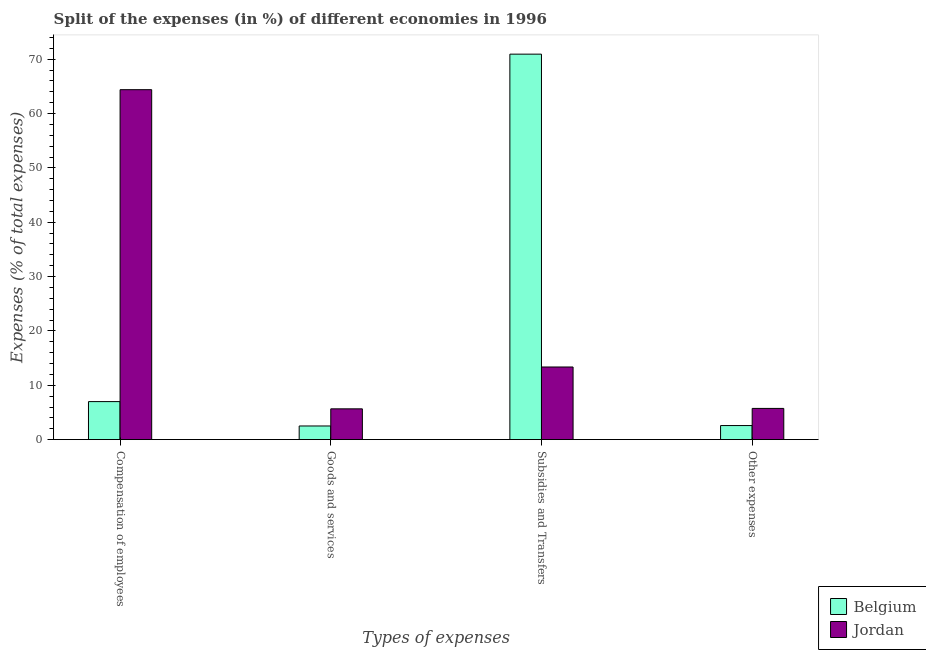How many groups of bars are there?
Keep it short and to the point. 4. Are the number of bars per tick equal to the number of legend labels?
Your answer should be very brief. Yes. Are the number of bars on each tick of the X-axis equal?
Ensure brevity in your answer.  Yes. What is the label of the 4th group of bars from the left?
Provide a succinct answer. Other expenses. What is the percentage of amount spent on goods and services in Belgium?
Ensure brevity in your answer.  2.51. Across all countries, what is the maximum percentage of amount spent on goods and services?
Give a very brief answer. 5.66. Across all countries, what is the minimum percentage of amount spent on subsidies?
Your response must be concise. 13.36. What is the total percentage of amount spent on compensation of employees in the graph?
Your answer should be very brief. 71.39. What is the difference between the percentage of amount spent on other expenses in Jordan and that in Belgium?
Your answer should be very brief. 3.15. What is the difference between the percentage of amount spent on compensation of employees in Jordan and the percentage of amount spent on other expenses in Belgium?
Provide a short and direct response. 61.81. What is the average percentage of amount spent on compensation of employees per country?
Provide a succinct answer. 35.69. What is the difference between the percentage of amount spent on compensation of employees and percentage of amount spent on other expenses in Belgium?
Ensure brevity in your answer.  4.41. In how many countries, is the percentage of amount spent on compensation of employees greater than 66 %?
Provide a succinct answer. 0. What is the ratio of the percentage of amount spent on goods and services in Jordan to that in Belgium?
Ensure brevity in your answer.  2.26. Is the difference between the percentage of amount spent on other expenses in Jordan and Belgium greater than the difference between the percentage of amount spent on compensation of employees in Jordan and Belgium?
Your response must be concise. No. What is the difference between the highest and the second highest percentage of amount spent on goods and services?
Offer a very short reply. 3.15. What is the difference between the highest and the lowest percentage of amount spent on other expenses?
Your answer should be compact. 3.15. Is the sum of the percentage of amount spent on other expenses in Belgium and Jordan greater than the maximum percentage of amount spent on subsidies across all countries?
Your answer should be very brief. No. What does the 2nd bar from the left in Goods and services represents?
Keep it short and to the point. Jordan. What does the 2nd bar from the right in Compensation of employees represents?
Provide a short and direct response. Belgium. Are all the bars in the graph horizontal?
Provide a succinct answer. No. How many countries are there in the graph?
Offer a terse response. 2. Does the graph contain any zero values?
Your answer should be compact. No. Where does the legend appear in the graph?
Offer a very short reply. Bottom right. What is the title of the graph?
Your answer should be very brief. Split of the expenses (in %) of different economies in 1996. Does "Aruba" appear as one of the legend labels in the graph?
Make the answer very short. No. What is the label or title of the X-axis?
Keep it short and to the point. Types of expenses. What is the label or title of the Y-axis?
Your answer should be compact. Expenses (% of total expenses). What is the Expenses (% of total expenses) of Belgium in Compensation of employees?
Offer a terse response. 6.99. What is the Expenses (% of total expenses) of Jordan in Compensation of employees?
Offer a very short reply. 64.4. What is the Expenses (% of total expenses) in Belgium in Goods and services?
Offer a terse response. 2.51. What is the Expenses (% of total expenses) of Jordan in Goods and services?
Give a very brief answer. 5.66. What is the Expenses (% of total expenses) in Belgium in Subsidies and Transfers?
Your answer should be compact. 70.93. What is the Expenses (% of total expenses) in Jordan in Subsidies and Transfers?
Your answer should be very brief. 13.36. What is the Expenses (% of total expenses) of Belgium in Other expenses?
Your response must be concise. 2.58. What is the Expenses (% of total expenses) of Jordan in Other expenses?
Ensure brevity in your answer.  5.74. Across all Types of expenses, what is the maximum Expenses (% of total expenses) of Belgium?
Give a very brief answer. 70.93. Across all Types of expenses, what is the maximum Expenses (% of total expenses) of Jordan?
Give a very brief answer. 64.4. Across all Types of expenses, what is the minimum Expenses (% of total expenses) in Belgium?
Ensure brevity in your answer.  2.51. Across all Types of expenses, what is the minimum Expenses (% of total expenses) in Jordan?
Offer a very short reply. 5.66. What is the total Expenses (% of total expenses) in Belgium in the graph?
Offer a terse response. 83.02. What is the total Expenses (% of total expenses) of Jordan in the graph?
Give a very brief answer. 89.16. What is the difference between the Expenses (% of total expenses) of Belgium in Compensation of employees and that in Goods and services?
Offer a terse response. 4.49. What is the difference between the Expenses (% of total expenses) in Jordan in Compensation of employees and that in Goods and services?
Your response must be concise. 58.73. What is the difference between the Expenses (% of total expenses) of Belgium in Compensation of employees and that in Subsidies and Transfers?
Your answer should be very brief. -63.94. What is the difference between the Expenses (% of total expenses) of Jordan in Compensation of employees and that in Subsidies and Transfers?
Provide a succinct answer. 51.03. What is the difference between the Expenses (% of total expenses) of Belgium in Compensation of employees and that in Other expenses?
Your response must be concise. 4.41. What is the difference between the Expenses (% of total expenses) in Jordan in Compensation of employees and that in Other expenses?
Make the answer very short. 58.66. What is the difference between the Expenses (% of total expenses) in Belgium in Goods and services and that in Subsidies and Transfers?
Offer a terse response. -68.43. What is the difference between the Expenses (% of total expenses) of Jordan in Goods and services and that in Subsidies and Transfers?
Offer a very short reply. -7.7. What is the difference between the Expenses (% of total expenses) in Belgium in Goods and services and that in Other expenses?
Your answer should be compact. -0.08. What is the difference between the Expenses (% of total expenses) in Jordan in Goods and services and that in Other expenses?
Your answer should be compact. -0.08. What is the difference between the Expenses (% of total expenses) of Belgium in Subsidies and Transfers and that in Other expenses?
Your answer should be compact. 68.35. What is the difference between the Expenses (% of total expenses) of Jordan in Subsidies and Transfers and that in Other expenses?
Offer a terse response. 7.62. What is the difference between the Expenses (% of total expenses) in Belgium in Compensation of employees and the Expenses (% of total expenses) in Jordan in Goods and services?
Provide a short and direct response. 1.33. What is the difference between the Expenses (% of total expenses) in Belgium in Compensation of employees and the Expenses (% of total expenses) in Jordan in Subsidies and Transfers?
Your answer should be compact. -6.37. What is the difference between the Expenses (% of total expenses) of Belgium in Compensation of employees and the Expenses (% of total expenses) of Jordan in Other expenses?
Keep it short and to the point. 1.26. What is the difference between the Expenses (% of total expenses) in Belgium in Goods and services and the Expenses (% of total expenses) in Jordan in Subsidies and Transfers?
Your answer should be very brief. -10.86. What is the difference between the Expenses (% of total expenses) in Belgium in Goods and services and the Expenses (% of total expenses) in Jordan in Other expenses?
Give a very brief answer. -3.23. What is the difference between the Expenses (% of total expenses) in Belgium in Subsidies and Transfers and the Expenses (% of total expenses) in Jordan in Other expenses?
Ensure brevity in your answer.  65.19. What is the average Expenses (% of total expenses) in Belgium per Types of expenses?
Ensure brevity in your answer.  20.75. What is the average Expenses (% of total expenses) in Jordan per Types of expenses?
Provide a succinct answer. 22.29. What is the difference between the Expenses (% of total expenses) in Belgium and Expenses (% of total expenses) in Jordan in Compensation of employees?
Your answer should be very brief. -57.4. What is the difference between the Expenses (% of total expenses) of Belgium and Expenses (% of total expenses) of Jordan in Goods and services?
Provide a short and direct response. -3.15. What is the difference between the Expenses (% of total expenses) of Belgium and Expenses (% of total expenses) of Jordan in Subsidies and Transfers?
Offer a very short reply. 57.57. What is the difference between the Expenses (% of total expenses) of Belgium and Expenses (% of total expenses) of Jordan in Other expenses?
Provide a succinct answer. -3.15. What is the ratio of the Expenses (% of total expenses) in Belgium in Compensation of employees to that in Goods and services?
Your response must be concise. 2.79. What is the ratio of the Expenses (% of total expenses) in Jordan in Compensation of employees to that in Goods and services?
Provide a succinct answer. 11.38. What is the ratio of the Expenses (% of total expenses) in Belgium in Compensation of employees to that in Subsidies and Transfers?
Provide a short and direct response. 0.1. What is the ratio of the Expenses (% of total expenses) in Jordan in Compensation of employees to that in Subsidies and Transfers?
Provide a short and direct response. 4.82. What is the ratio of the Expenses (% of total expenses) of Belgium in Compensation of employees to that in Other expenses?
Your response must be concise. 2.71. What is the ratio of the Expenses (% of total expenses) in Jordan in Compensation of employees to that in Other expenses?
Provide a short and direct response. 11.22. What is the ratio of the Expenses (% of total expenses) of Belgium in Goods and services to that in Subsidies and Transfers?
Make the answer very short. 0.04. What is the ratio of the Expenses (% of total expenses) of Jordan in Goods and services to that in Subsidies and Transfers?
Provide a succinct answer. 0.42. What is the ratio of the Expenses (% of total expenses) in Belgium in Goods and services to that in Other expenses?
Your answer should be very brief. 0.97. What is the ratio of the Expenses (% of total expenses) in Jordan in Goods and services to that in Other expenses?
Your answer should be compact. 0.99. What is the ratio of the Expenses (% of total expenses) of Belgium in Subsidies and Transfers to that in Other expenses?
Make the answer very short. 27.44. What is the ratio of the Expenses (% of total expenses) of Jordan in Subsidies and Transfers to that in Other expenses?
Offer a terse response. 2.33. What is the difference between the highest and the second highest Expenses (% of total expenses) of Belgium?
Keep it short and to the point. 63.94. What is the difference between the highest and the second highest Expenses (% of total expenses) in Jordan?
Provide a succinct answer. 51.03. What is the difference between the highest and the lowest Expenses (% of total expenses) in Belgium?
Your answer should be compact. 68.43. What is the difference between the highest and the lowest Expenses (% of total expenses) in Jordan?
Your answer should be very brief. 58.73. 